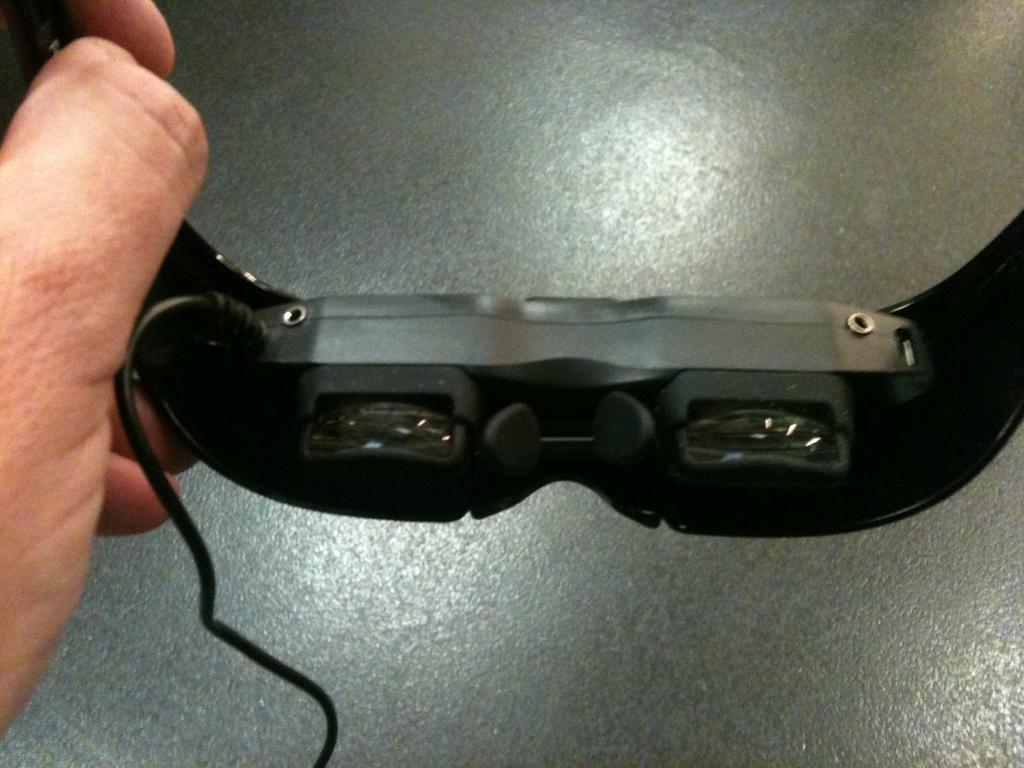Can you describe this image briefly? In this image we can see person's hand holding goggles. At the bottom there is floor. 